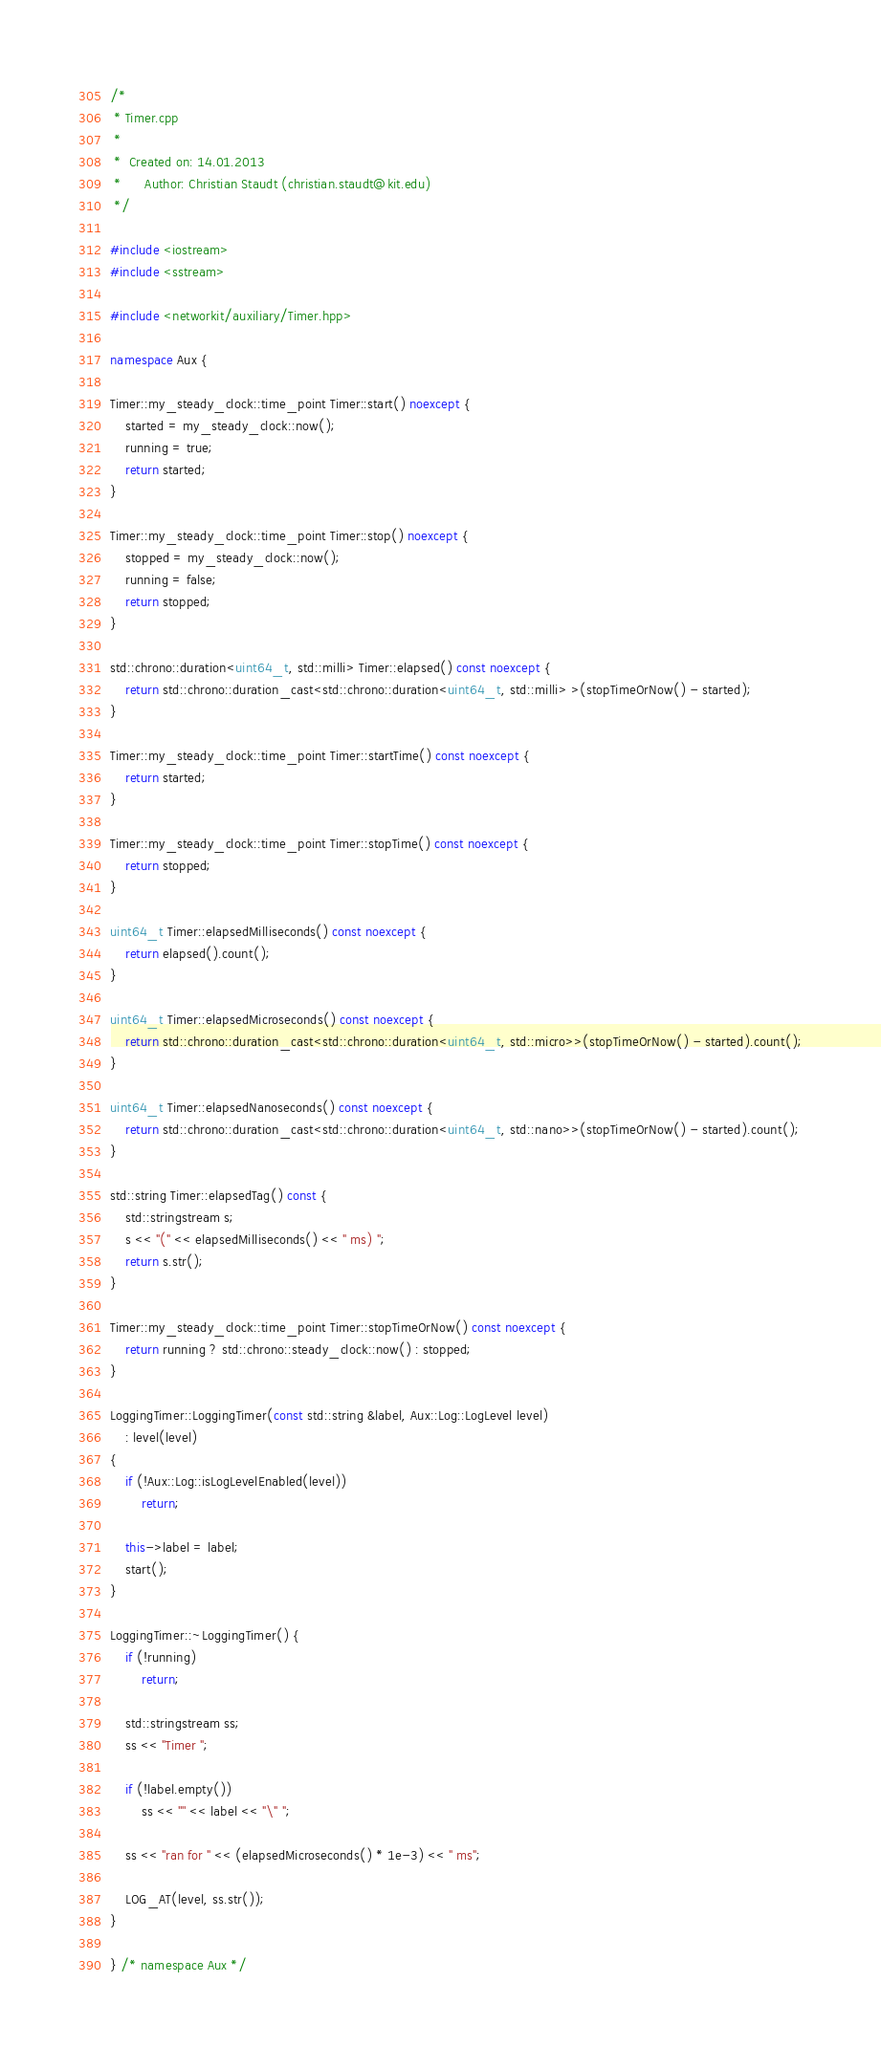<code> <loc_0><loc_0><loc_500><loc_500><_C++_>/*
 * Timer.cpp
 *
 *  Created on: 14.01.2013
 *      Author: Christian Staudt (christian.staudt@kit.edu)
 */

#include <iostream>
#include <sstream>

#include <networkit/auxiliary/Timer.hpp>

namespace Aux {

Timer::my_steady_clock::time_point Timer::start() noexcept {
	started = my_steady_clock::now();
	running = true;
	return started;
}

Timer::my_steady_clock::time_point Timer::stop() noexcept {
	stopped = my_steady_clock::now();
	running = false;
	return stopped;
}

std::chrono::duration<uint64_t, std::milli> Timer::elapsed() const noexcept {
	return std::chrono::duration_cast<std::chrono::duration<uint64_t, std::milli> >(stopTimeOrNow() - started);
}

Timer::my_steady_clock::time_point Timer::startTime() const noexcept {
	return started;
}

Timer::my_steady_clock::time_point Timer::stopTime() const noexcept {
	return stopped;
}

uint64_t Timer::elapsedMilliseconds() const noexcept {
	return elapsed().count();
}

uint64_t Timer::elapsedMicroseconds() const noexcept {
	return std::chrono::duration_cast<std::chrono::duration<uint64_t, std::micro>>(stopTimeOrNow() - started).count();
}

uint64_t Timer::elapsedNanoseconds() const noexcept {
	return std::chrono::duration_cast<std::chrono::duration<uint64_t, std::nano>>(stopTimeOrNow() - started).count();
}

std::string Timer::elapsedTag() const {
	std::stringstream s;
	s << "(" << elapsedMilliseconds() << " ms) ";
	return s.str();
}

Timer::my_steady_clock::time_point Timer::stopTimeOrNow() const noexcept {
	return running ? std::chrono::steady_clock::now() : stopped;
}

LoggingTimer::LoggingTimer(const std::string &label, Aux::Log::LogLevel level)
	: level(level)
{
	if (!Aux::Log::isLogLevelEnabled(level))
		return;

	this->label = label;
	start();
}

LoggingTimer::~LoggingTimer() {
	if (!running)
		return;

	std::stringstream ss;
	ss << "Timer ";

	if (!label.empty())
		ss << '"' << label << "\" ";

	ss << "ran for " << (elapsedMicroseconds() * 1e-3) << " ms";

	LOG_AT(level, ss.str());
}

} /* namespace Aux */
</code> 